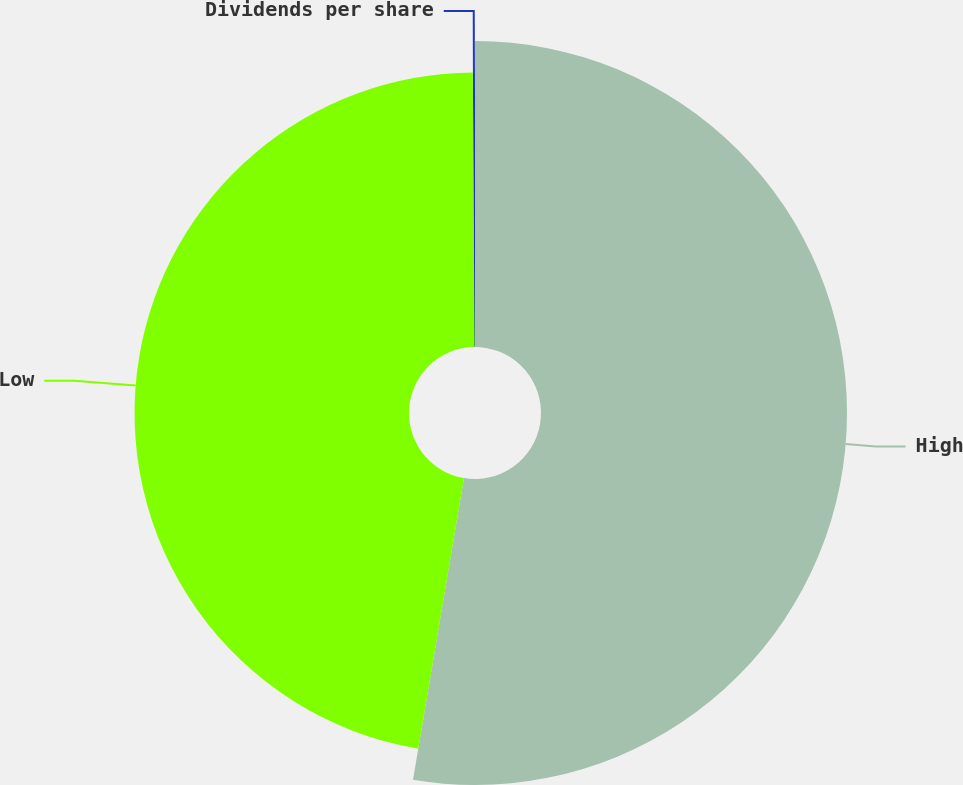Convert chart to OTSL. <chart><loc_0><loc_0><loc_500><loc_500><pie_chart><fcel>High<fcel>Low<fcel>Dividends per share<nl><fcel>52.67%<fcel>47.24%<fcel>0.1%<nl></chart> 